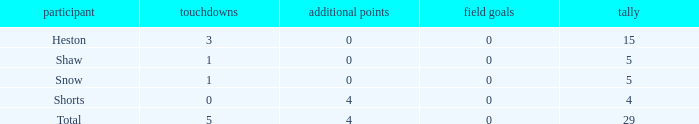What is the sum of all the touchdowns when the player had more than 0 extra points and less than 0 field goals? None. 